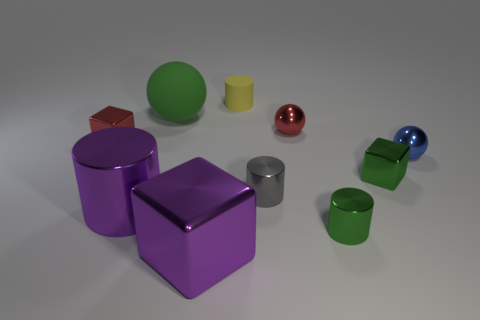How many big objects are either purple blocks or balls?
Offer a very short reply. 2. Is there anything else that has the same color as the big ball?
Provide a succinct answer. Yes. What is the shape of the small green thing that is the same material as the green cylinder?
Give a very brief answer. Cube. What is the size of the purple object left of the big green rubber sphere?
Your answer should be very brief. Large. The blue object has what shape?
Make the answer very short. Sphere. There is a sphere that is to the left of the tiny yellow object; does it have the same size as the purple object behind the large purple block?
Your answer should be compact. Yes. What is the size of the green metallic object behind the shiny cylinder to the left of the thing that is behind the green matte ball?
Ensure brevity in your answer.  Small. The tiny red thing to the left of the red thing that is behind the tiny red metallic object that is on the left side of the large green sphere is what shape?
Make the answer very short. Cube. There is a purple metal object that is left of the green ball; what shape is it?
Offer a terse response. Cylinder. Are the purple cylinder and the big thing that is behind the large metallic cylinder made of the same material?
Give a very brief answer. No. 